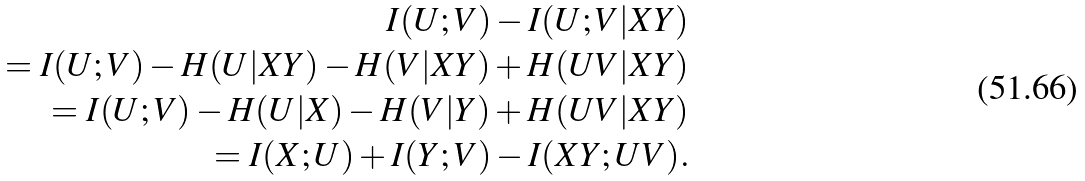Convert formula to latex. <formula><loc_0><loc_0><loc_500><loc_500>I ( U ; V ) - I ( U ; V | X Y ) \\ = I ( U ; V ) - H ( U | X Y ) - H ( V | X Y ) + H ( U V | X Y ) \\ = I ( U ; V ) - H ( U | X ) - H ( V | Y ) + H ( U V | X Y ) \\ = I ( X ; U ) + I ( Y ; V ) - I ( X Y ; U V ) .</formula> 